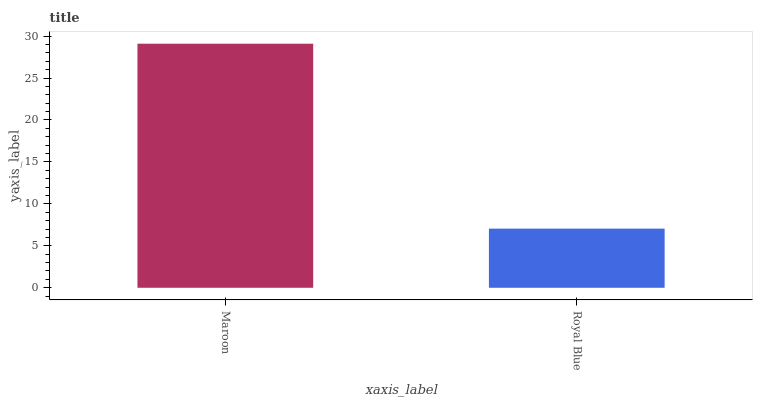Is Royal Blue the minimum?
Answer yes or no. Yes. Is Maroon the maximum?
Answer yes or no. Yes. Is Royal Blue the maximum?
Answer yes or no. No. Is Maroon greater than Royal Blue?
Answer yes or no. Yes. Is Royal Blue less than Maroon?
Answer yes or no. Yes. Is Royal Blue greater than Maroon?
Answer yes or no. No. Is Maroon less than Royal Blue?
Answer yes or no. No. Is Maroon the high median?
Answer yes or no. Yes. Is Royal Blue the low median?
Answer yes or no. Yes. Is Royal Blue the high median?
Answer yes or no. No. Is Maroon the low median?
Answer yes or no. No. 